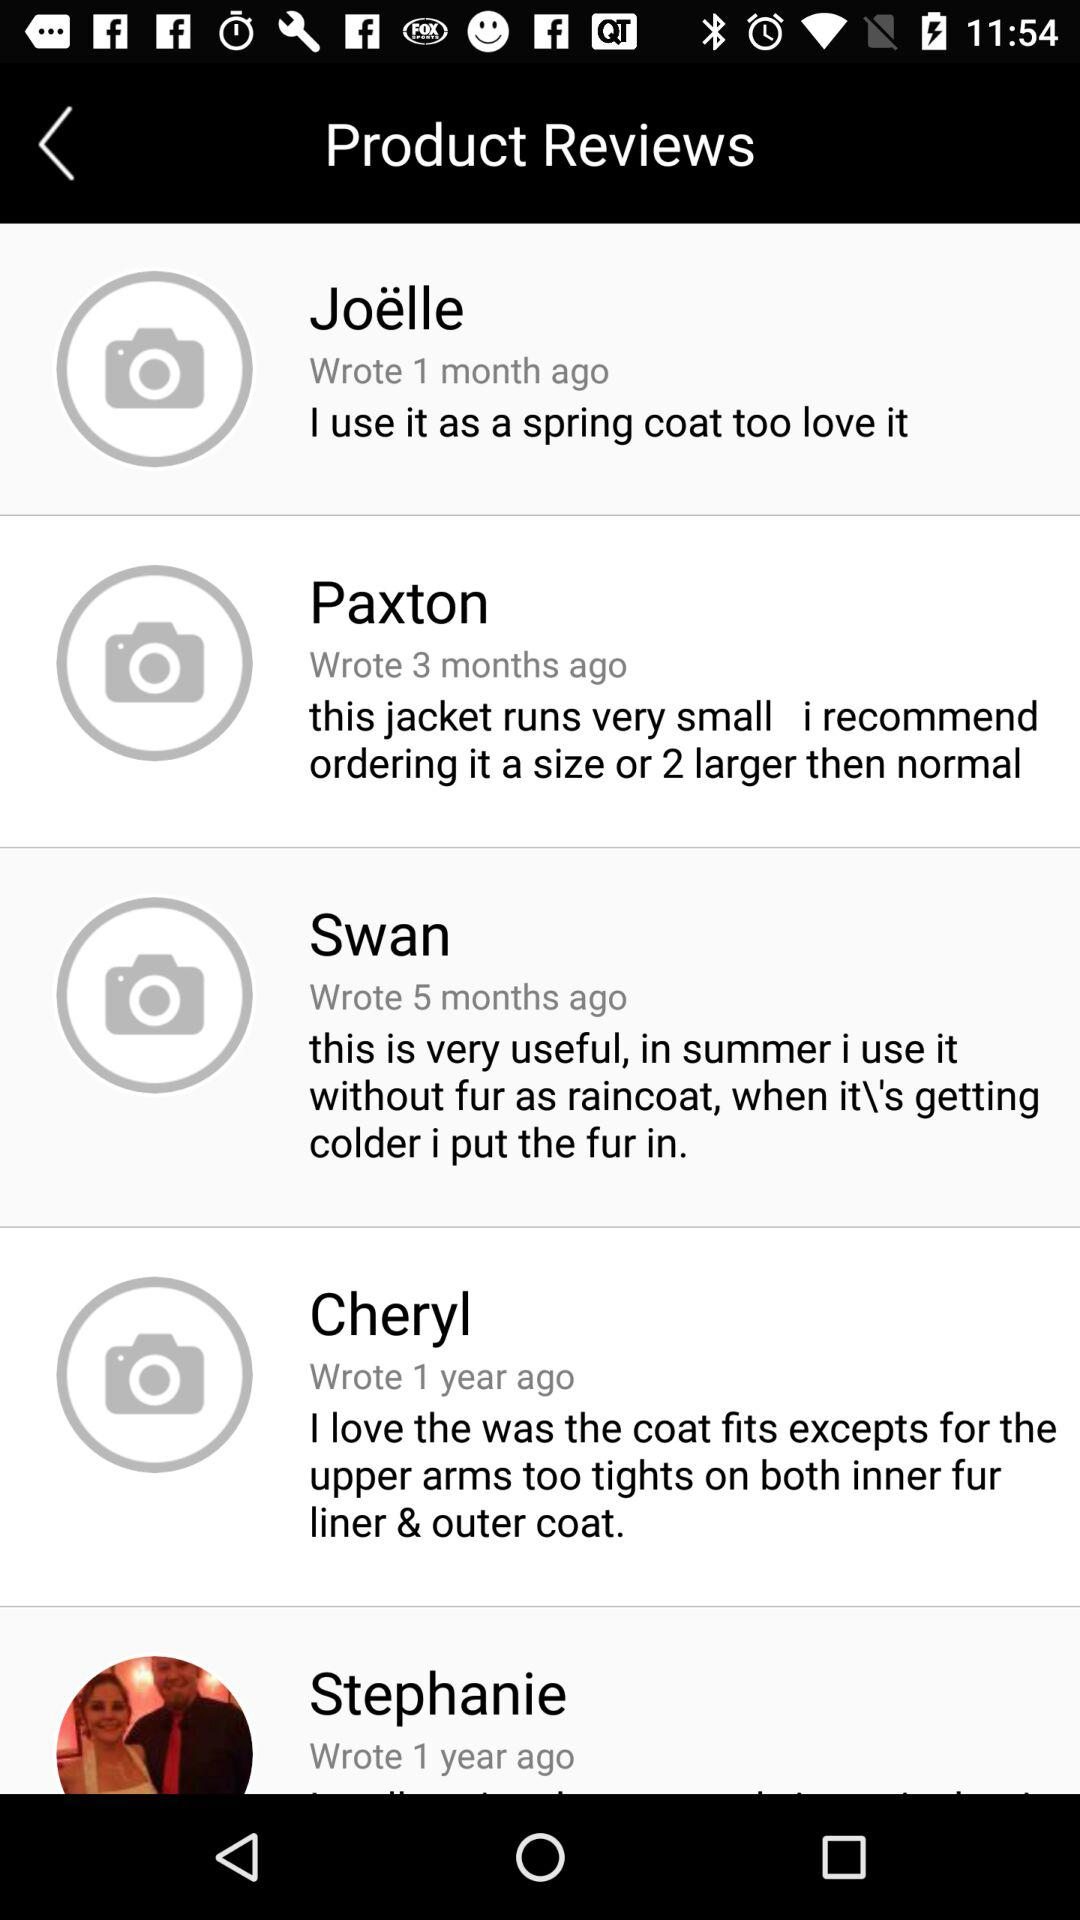How many months ago did Paxton post a review? Paxton posted a review 3 months ago. 